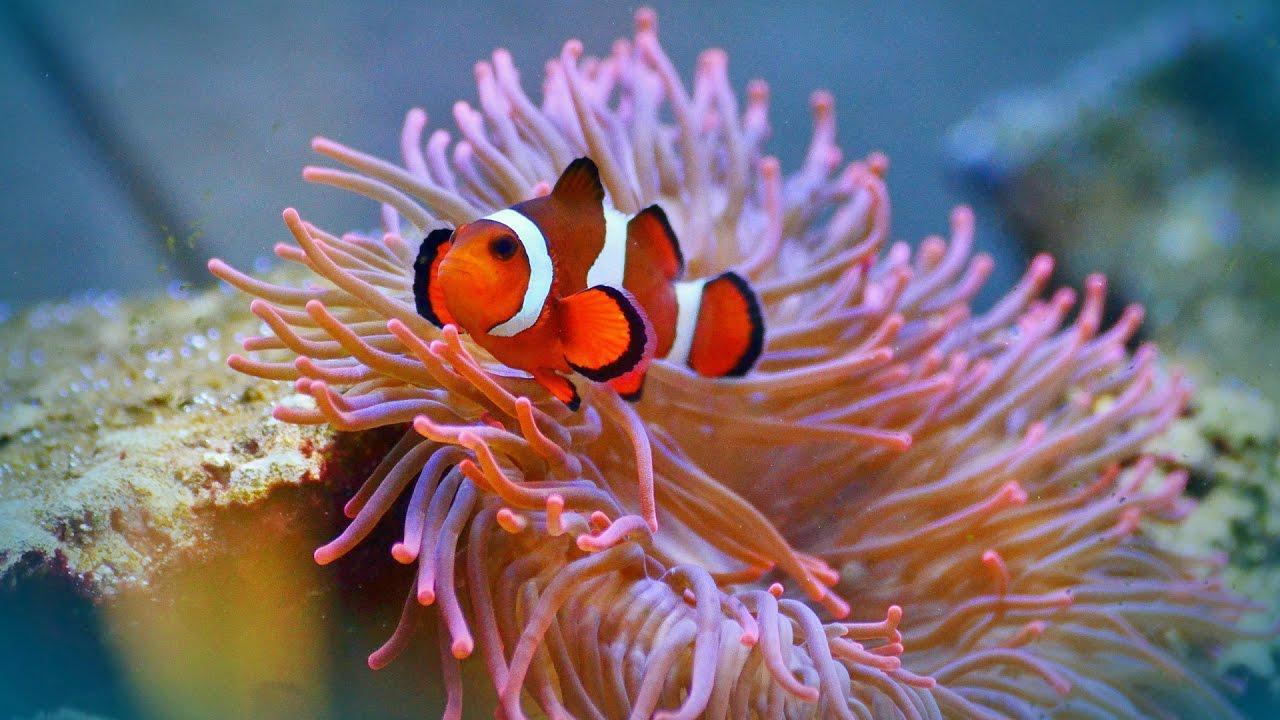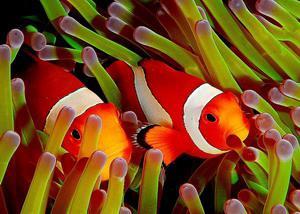The first image is the image on the left, the second image is the image on the right. Assess this claim about the two images: "Exactly two clown fish swim through anemone tendrils in one image.". Correct or not? Answer yes or no. Yes. 